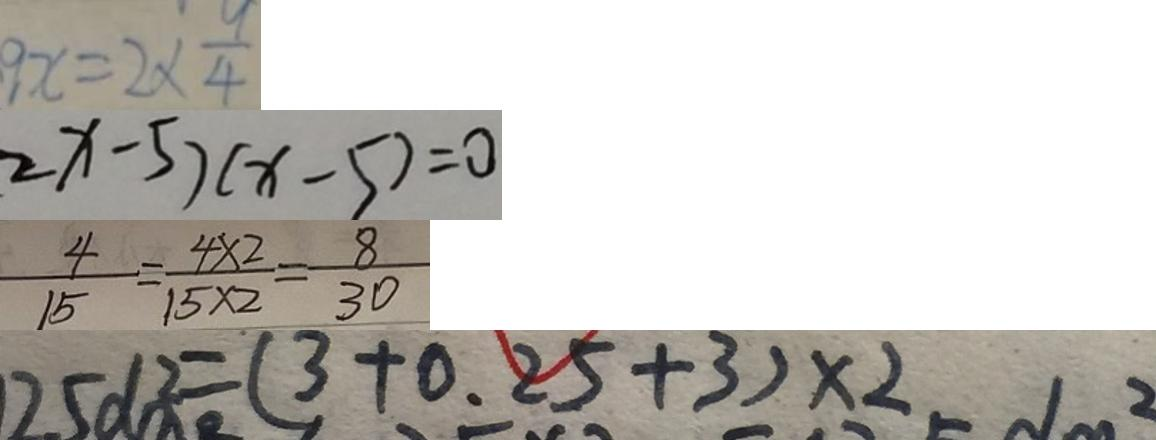Convert formula to latex. <formula><loc_0><loc_0><loc_500><loc_500>9 x = 2 \times \frac { 9 } { 4 } 
 2 x - 5 ) ( x - 5 ) = 0 
 \frac { 4 } { 1 5 } = \frac { 4 \times 2 } { 1 5 \times 2 } = \frac { 8 } { 3 0 } 
 2 5 d m ^ { 2 } = ( 3 + 0 . 2 5 + 3 ) \times 2</formula> 